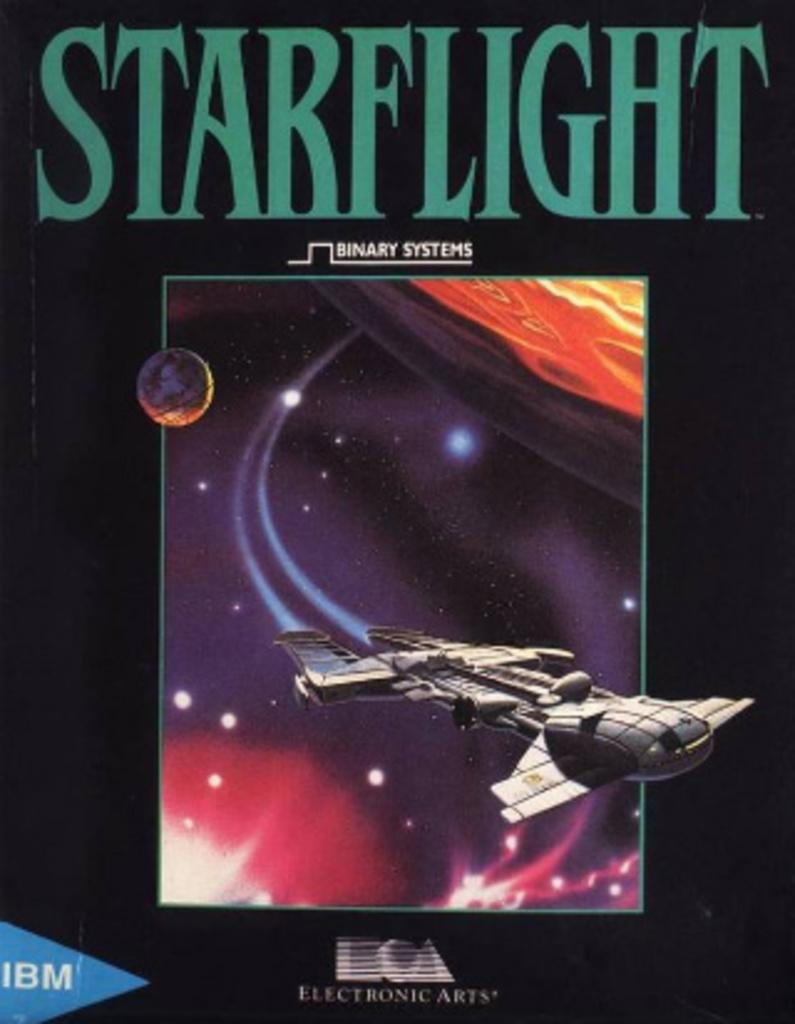What is present in the image that contains both text and an image? There is a poster in the image that contains text and an image. Can you describe the content of the poster? The poster contains text and an image, but the specific content cannot be determined from the provided facts. What type of bait is being used to catch fish in the image? There is no mention of fish or bait in the image, as the facts only mention a poster containing text and an image. 